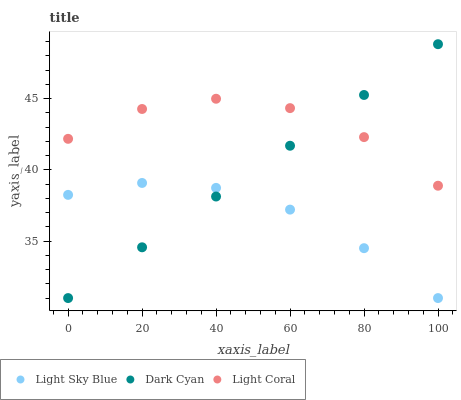Does Light Sky Blue have the minimum area under the curve?
Answer yes or no. Yes. Does Light Coral have the maximum area under the curve?
Answer yes or no. Yes. Does Light Coral have the minimum area under the curve?
Answer yes or no. No. Does Light Sky Blue have the maximum area under the curve?
Answer yes or no. No. Is Dark Cyan the smoothest?
Answer yes or no. Yes. Is Light Coral the roughest?
Answer yes or no. Yes. Is Light Sky Blue the smoothest?
Answer yes or no. No. Is Light Sky Blue the roughest?
Answer yes or no. No. Does Dark Cyan have the lowest value?
Answer yes or no. Yes. Does Light Coral have the lowest value?
Answer yes or no. No. Does Dark Cyan have the highest value?
Answer yes or no. Yes. Does Light Coral have the highest value?
Answer yes or no. No. Is Light Sky Blue less than Light Coral?
Answer yes or no. Yes. Is Light Coral greater than Light Sky Blue?
Answer yes or no. Yes. Does Light Coral intersect Dark Cyan?
Answer yes or no. Yes. Is Light Coral less than Dark Cyan?
Answer yes or no. No. Is Light Coral greater than Dark Cyan?
Answer yes or no. No. Does Light Sky Blue intersect Light Coral?
Answer yes or no. No. 